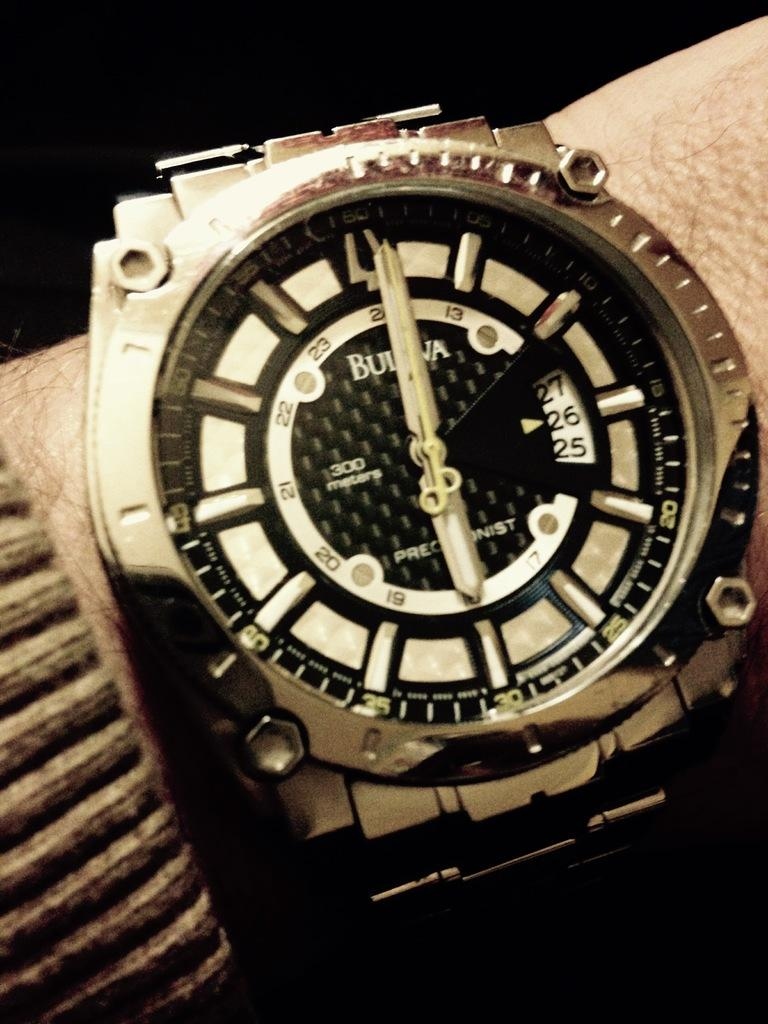Provide a one-sentence caption for the provided image. A Bulova watch says it is six o'clock. 